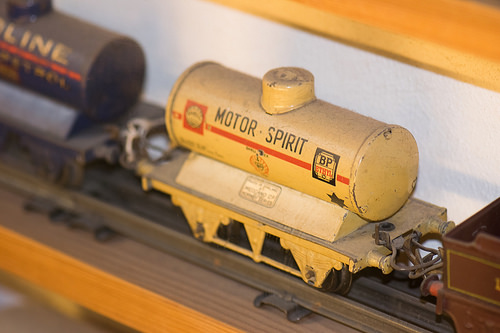<image>
Can you confirm if the tanker is above the table? Yes. The tanker is positioned above the table in the vertical space, higher up in the scene. 